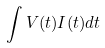<formula> <loc_0><loc_0><loc_500><loc_500>\int V ( t ) I ( t ) d t</formula> 